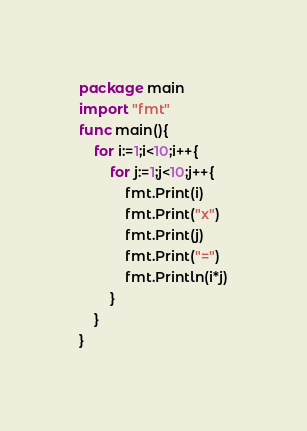<code> <loc_0><loc_0><loc_500><loc_500><_Go_>package main
import "fmt"
func main(){
    for i:=1;i<10;i++{
        for j:=1;j<10;j++{
            fmt.Print(i)
            fmt.Print("x")
            fmt.Print(j)
            fmt.Print("=")
            fmt.Println(i*j)
        }
    }
}

</code> 